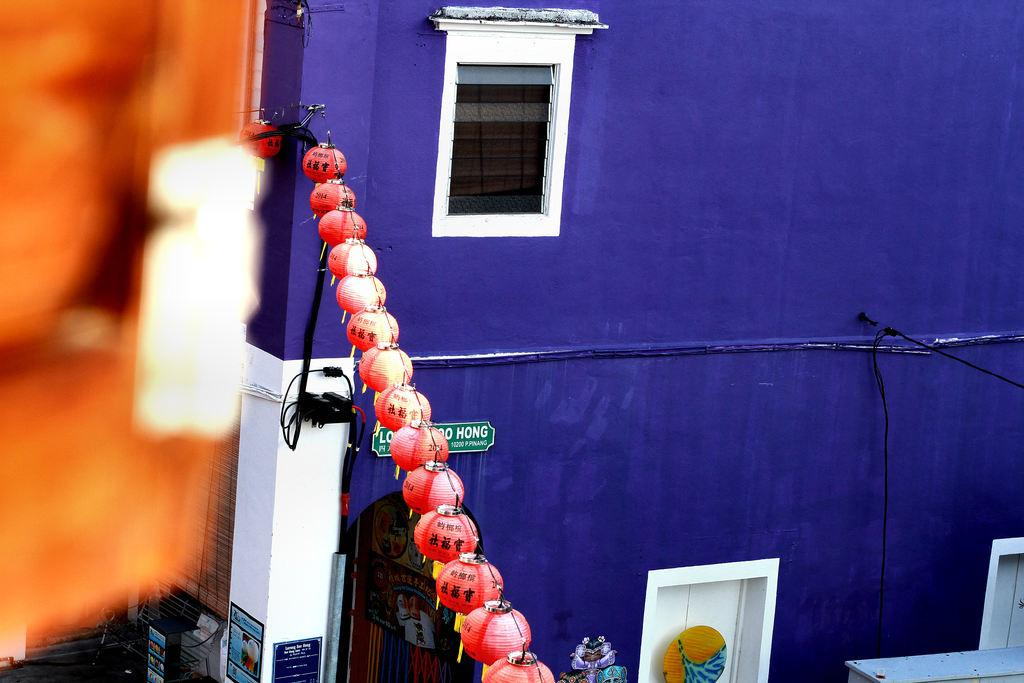What can be seen arranged in a straight line in the image? There are lights arranged in a straight line in the image. What type of building is present in the image? There is a blue color building in the image. Does the building have any specific features? Yes, the building has a window. How many tickets are visible on the window of the blue building in the image? There are no tickets visible on the window of the blue building in the image. Can you see any cats on the roof of the blue building in the image? There are no cats present in the image. 